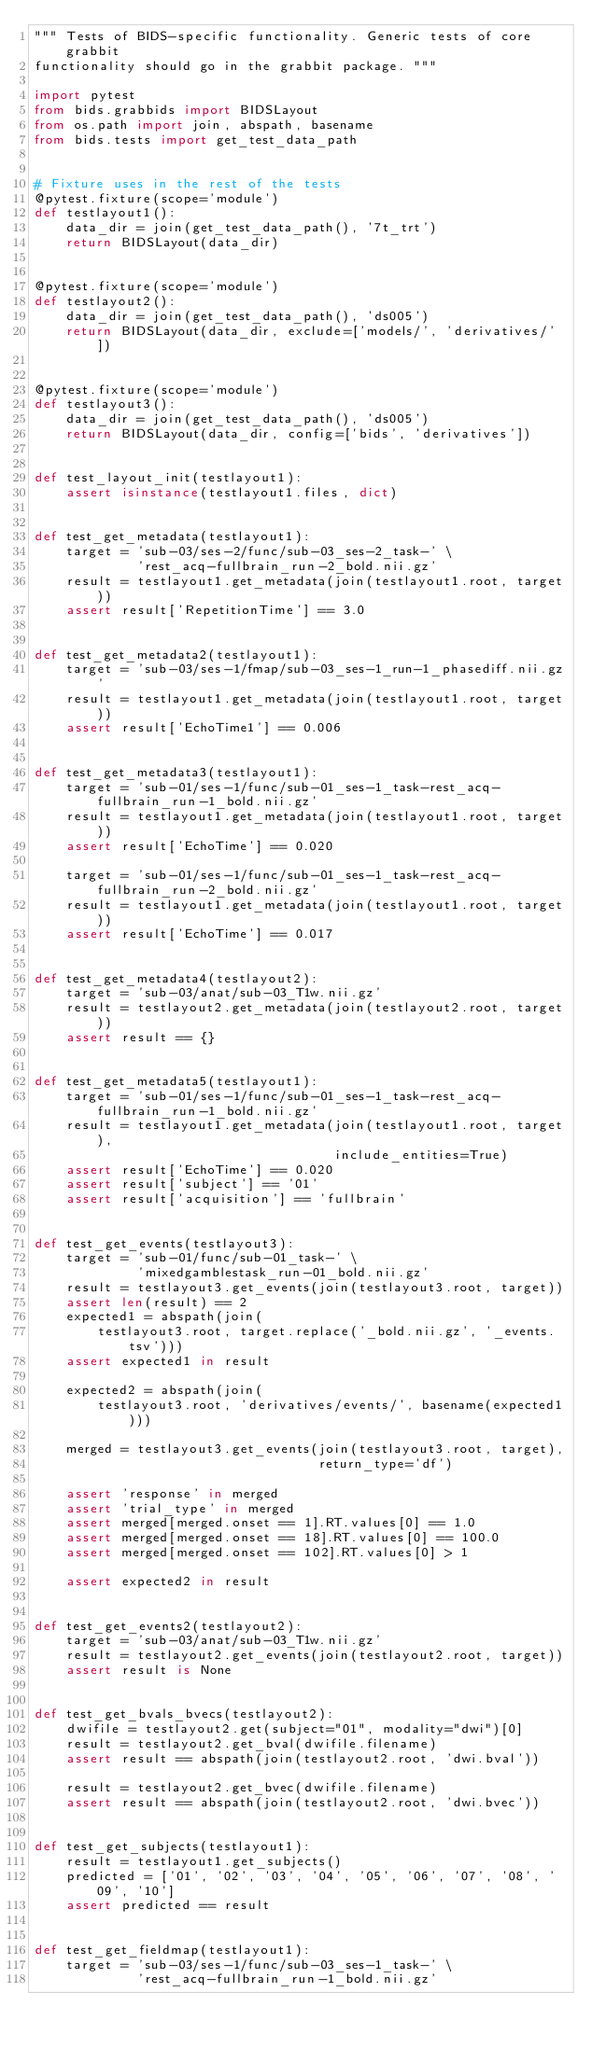Convert code to text. <code><loc_0><loc_0><loc_500><loc_500><_Python_>""" Tests of BIDS-specific functionality. Generic tests of core grabbit
functionality should go in the grabbit package. """

import pytest
from bids.grabbids import BIDSLayout
from os.path import join, abspath, basename
from bids.tests import get_test_data_path


# Fixture uses in the rest of the tests
@pytest.fixture(scope='module')
def testlayout1():
    data_dir = join(get_test_data_path(), '7t_trt')
    return BIDSLayout(data_dir)


@pytest.fixture(scope='module')
def testlayout2():
    data_dir = join(get_test_data_path(), 'ds005')
    return BIDSLayout(data_dir, exclude=['models/', 'derivatives/'])


@pytest.fixture(scope='module')
def testlayout3():
    data_dir = join(get_test_data_path(), 'ds005')
    return BIDSLayout(data_dir, config=['bids', 'derivatives'])


def test_layout_init(testlayout1):
    assert isinstance(testlayout1.files, dict)


def test_get_metadata(testlayout1):
    target = 'sub-03/ses-2/func/sub-03_ses-2_task-' \
             'rest_acq-fullbrain_run-2_bold.nii.gz'
    result = testlayout1.get_metadata(join(testlayout1.root, target))
    assert result['RepetitionTime'] == 3.0


def test_get_metadata2(testlayout1):
    target = 'sub-03/ses-1/fmap/sub-03_ses-1_run-1_phasediff.nii.gz'
    result = testlayout1.get_metadata(join(testlayout1.root, target))
    assert result['EchoTime1'] == 0.006


def test_get_metadata3(testlayout1):
    target = 'sub-01/ses-1/func/sub-01_ses-1_task-rest_acq-fullbrain_run-1_bold.nii.gz'
    result = testlayout1.get_metadata(join(testlayout1.root, target))
    assert result['EchoTime'] == 0.020

    target = 'sub-01/ses-1/func/sub-01_ses-1_task-rest_acq-fullbrain_run-2_bold.nii.gz'
    result = testlayout1.get_metadata(join(testlayout1.root, target))
    assert result['EchoTime'] == 0.017


def test_get_metadata4(testlayout2):
    target = 'sub-03/anat/sub-03_T1w.nii.gz'
    result = testlayout2.get_metadata(join(testlayout2.root, target))
    assert result == {}


def test_get_metadata5(testlayout1):
    target = 'sub-01/ses-1/func/sub-01_ses-1_task-rest_acq-fullbrain_run-1_bold.nii.gz'
    result = testlayout1.get_metadata(join(testlayout1.root, target),
                                      include_entities=True)
    assert result['EchoTime'] == 0.020
    assert result['subject'] == '01'
    assert result['acquisition'] == 'fullbrain'


def test_get_events(testlayout3):
    target = 'sub-01/func/sub-01_task-' \
             'mixedgamblestask_run-01_bold.nii.gz'
    result = testlayout3.get_events(join(testlayout3.root, target))
    assert len(result) == 2
    expected1 = abspath(join(
        testlayout3.root, target.replace('_bold.nii.gz', '_events.tsv')))
    assert expected1 in result

    expected2 = abspath(join(
        testlayout3.root, 'derivatives/events/', basename(expected1)))

    merged = testlayout3.get_events(join(testlayout3.root, target),
                                    return_type='df')

    assert 'response' in merged
    assert 'trial_type' in merged
    assert merged[merged.onset == 1].RT.values[0] == 1.0
    assert merged[merged.onset == 18].RT.values[0] == 100.0
    assert merged[merged.onset == 102].RT.values[0] > 1

    assert expected2 in result


def test_get_events2(testlayout2):
    target = 'sub-03/anat/sub-03_T1w.nii.gz'
    result = testlayout2.get_events(join(testlayout2.root, target))
    assert result is None


def test_get_bvals_bvecs(testlayout2):
    dwifile = testlayout2.get(subject="01", modality="dwi")[0]
    result = testlayout2.get_bval(dwifile.filename)
    assert result == abspath(join(testlayout2.root, 'dwi.bval'))

    result = testlayout2.get_bvec(dwifile.filename)
    assert result == abspath(join(testlayout2.root, 'dwi.bvec'))


def test_get_subjects(testlayout1):
    result = testlayout1.get_subjects()
    predicted = ['01', '02', '03', '04', '05', '06', '07', '08', '09', '10']
    assert predicted == result


def test_get_fieldmap(testlayout1):
    target = 'sub-03/ses-1/func/sub-03_ses-1_task-' \
             'rest_acq-fullbrain_run-1_bold.nii.gz'</code> 